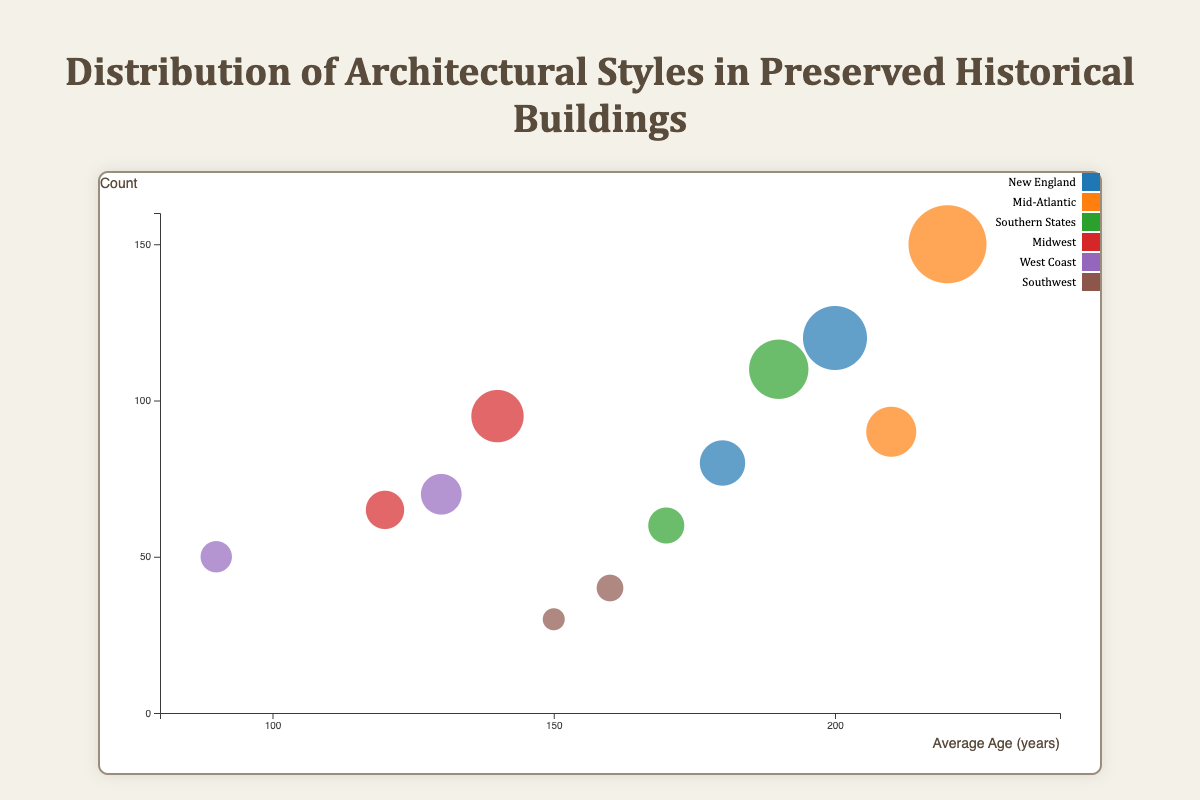What is the average age for buildings in the Mid-Atlantic region? To determine the average age for buildings in the Mid-Atlantic region, observe the bubbles representing this region on the x-axis (Age). The Mid-Atlantic has two types: Colonial (220 years) and Georgian (210 years). Averaging these values ((220 + 210) / 2) will give the answer.
Answer: 215 years Which region has the highest count of Colonial buildings? Locate the bubbles corresponding to Colonial architecture across different regions and compare their sizes (Count). The Mid-Atlantic region has a larger bubble (150) compared to New England (120).
Answer: Mid-Atlantic How many types of architectural styles are represented in the Southern States? Identify the bubbles labeled as belonging to the Southern States and count the different architectural style names. The Southern States have Greek Revival and Plantation.
Answer: 2 Which architectural style appears most frequently in the Midwest region? Observe the Midwest region's bubbles and compare their sizes (Count). Victorian has a count of 95, while Craftsman has 65. Victorian appears more frequently.
Answer: Victorian What is the difference in average age between the oldest and the youngest buildings across all regions? Identify the bubbles with the highest and lowest values on the x-axis (Age). The oldest (Mid-Atlantic Colonial, 220 years) and the youngest (West Coast Modern, 90 years) differ by (220 - 90) years.
Answer: 130 years Are there more modern buildings on the West Coast or Pueblo Revival buildings in the Southwest? Compare the sizes of the bubbles representing these architectural styles in their respective regions. West Coast Modern has a count of 50, while Southwest Pueblo Revival has 40. West Coast has more.
Answer: West Coast Which region has the widest variety of architectural styles? Count the number of different architectural styles represented by bubbles within each region. The region with the most distinct styles is New England (Colonial, Federal = 2).
Answer: New England What is the total count of buildings on the West Coast? Sum the counts of all architectural styles in the West Coast region. Spanish Colonial Revival (70) + Modern (50) gives a total of 120 buildings.
Answer: 120 How does the average building age in the Midwest compare to that in New England? Average the ages of buildings in each region: Midwest (Victorian: 140, Craftsman: 120) with (140 + 120) / 2 = 130 years. New England has (Colonial: 200, Federal: 180) with (200 + 180) / 2 = 190 years. Compare the results.
Answer: Midwest: 130 years, New England: 190 years Which architectural style spans the greatest range in average age values? Compare the widths on the x-axis (Age) for each architectural style across all regions. Colonial spans from New England (200 years) to Mid-Atlantic (220 years), giving a 20-year range. No other styles span a greater age range.
Answer: Colonial 